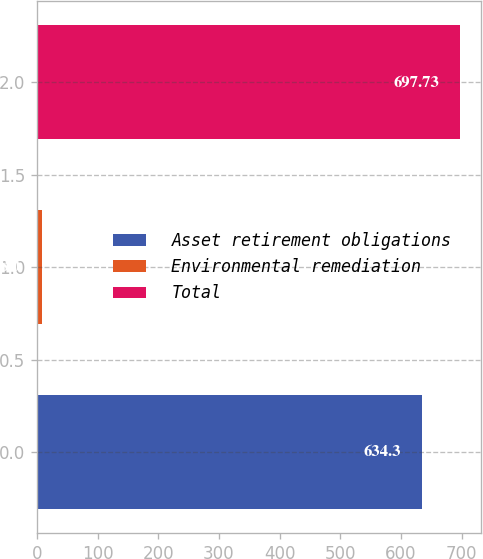<chart> <loc_0><loc_0><loc_500><loc_500><bar_chart><fcel>Asset retirement obligations<fcel>Environmental remediation<fcel>Total<nl><fcel>634.3<fcel>8<fcel>697.73<nl></chart> 